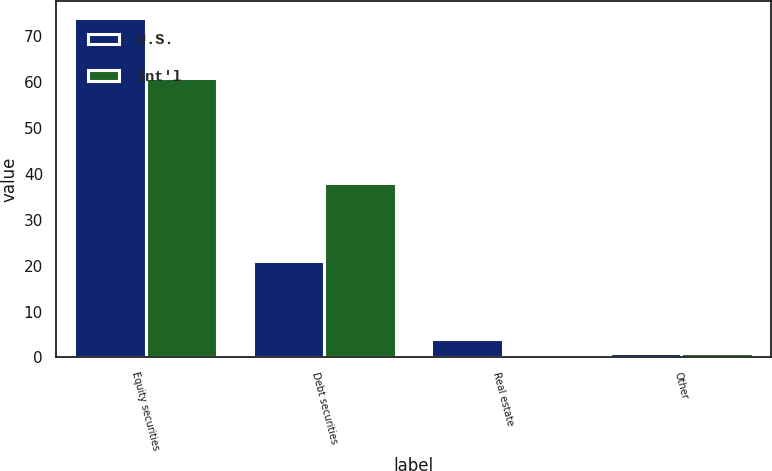Convert chart to OTSL. <chart><loc_0><loc_0><loc_500><loc_500><stacked_bar_chart><ecel><fcel>Equity securities<fcel>Debt securities<fcel>Real estate<fcel>Other<nl><fcel>U.S.<fcel>74<fcel>21<fcel>4<fcel>1<nl><fcel>Int'l<fcel>61<fcel>38<fcel>0<fcel>1<nl></chart> 